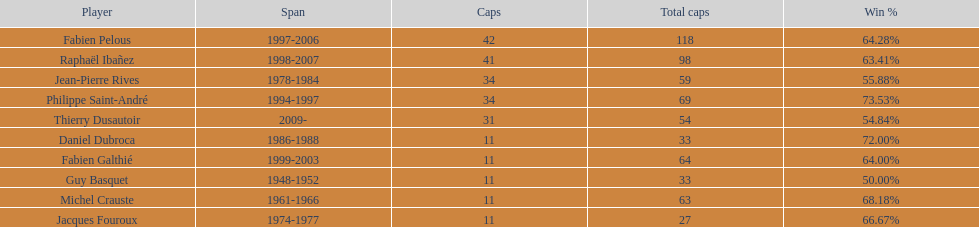How many captains played 11 capped matches? 5. Help me parse the entirety of this table. {'header': ['Player', 'Span', 'Caps', 'Total caps', 'Win\xa0%'], 'rows': [['Fabien Pelous', '1997-2006', '42', '118', '64.28%'], ['Raphaël Ibañez', '1998-2007', '41', '98', '63.41%'], ['Jean-Pierre Rives', '1978-1984', '34', '59', '55.88%'], ['Philippe Saint-André', '1994-1997', '34', '69', '73.53%'], ['Thierry Dusautoir', '2009-', '31', '54', '54.84%'], ['Daniel Dubroca', '1986-1988', '11', '33', '72.00%'], ['Fabien Galthié', '1999-2003', '11', '64', '64.00%'], ['Guy Basquet', '1948-1952', '11', '33', '50.00%'], ['Michel Crauste', '1961-1966', '11', '63', '68.18%'], ['Jacques Fouroux', '1974-1977', '11', '27', '66.67%']]} 